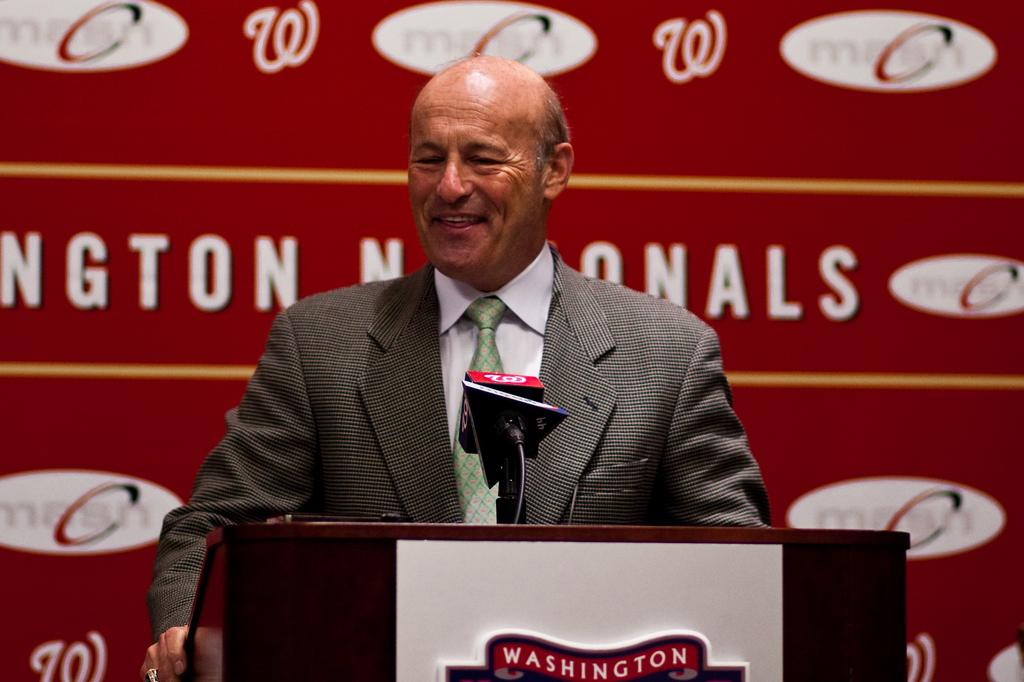Who is present in the image? There is a man in the image. What is the man standing beside? The man is standing beside a speaker stand. What can be found on the speaker stand? The speaker stand contains some text and a microphone. Can you describe the text on the backside of the speaker stand? There is text visible on the backside of the speaker stand. What type of celery is being used as a prop in the image? There is no celery present in the image. What kind of beast is lurking behind the speaker stand? There is no beast present in the image. 